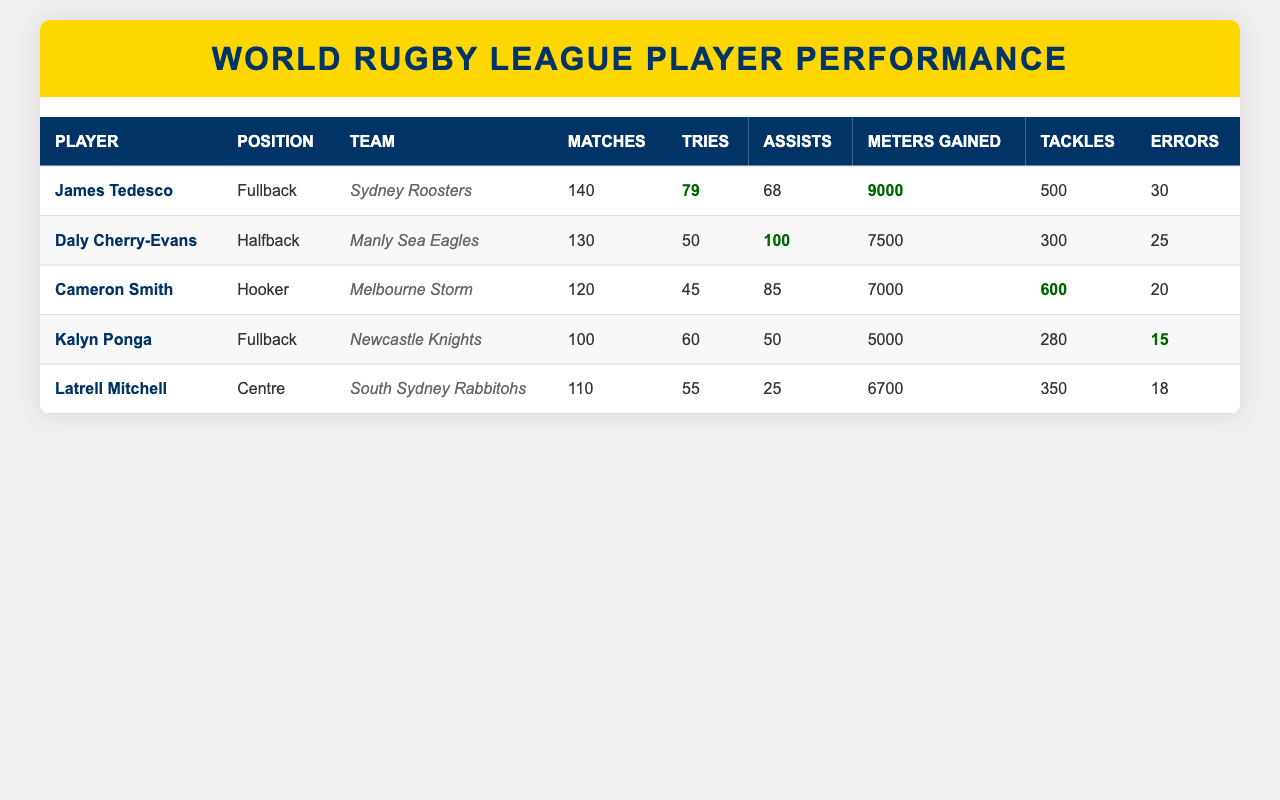What is the total number of tries scored by all players? To find the total number of tries, we sum the tries scored by each player: 79 + 50 + 45 + 60 + 55 = 289.
Answer: 289 Who has the highest number of meters gained? Looking at the Meters Gained column, James Tedesco has the highest amount with 9000 meters.
Answer: James Tedesco Is it true that Kalyn Ponga has more assists than tries? Kalyn Ponga has 50 assists and 60 tries; since 50 is less than 60, this statement is false.
Answer: No What is the average number of matches played by these players? We calculate the average by summing the matches played: 140 + 130 + 120 + 100 + 110 = 700. Then, dividing by the number of players (5): 700 / 5 = 140.
Answer: 140 How many players have scored 50 tries or more? Checking the Tries column, James Tedesco (79), Kalyn Ponga (60), and Latrell Mitchell (55) scored 50 or more tries. There are three players in total.
Answer: 3 Which player has the fewest errors? Upon reviewing the Errors column, Kalyn Ponga has made the fewest errors with 15.
Answer: Kalyn Ponga What is the difference in assists between the top two players? The top two players in assists are Daly Cherry-Evans (100) and Cameron Smith (85). 100 - 85 = 15.
Answer: 15 Which player has the highest tackle count? Based on the Tackle column, Cameron Smith has the highest number of tackles with 600.
Answer: Cameron Smith How many total meters did the players gain who play as Fullbacks? The Fullbacks are James Tedesco and Kalyn Ponga. They gained a total of 9000 + 5000 = 14000 meters.
Answer: 14000 